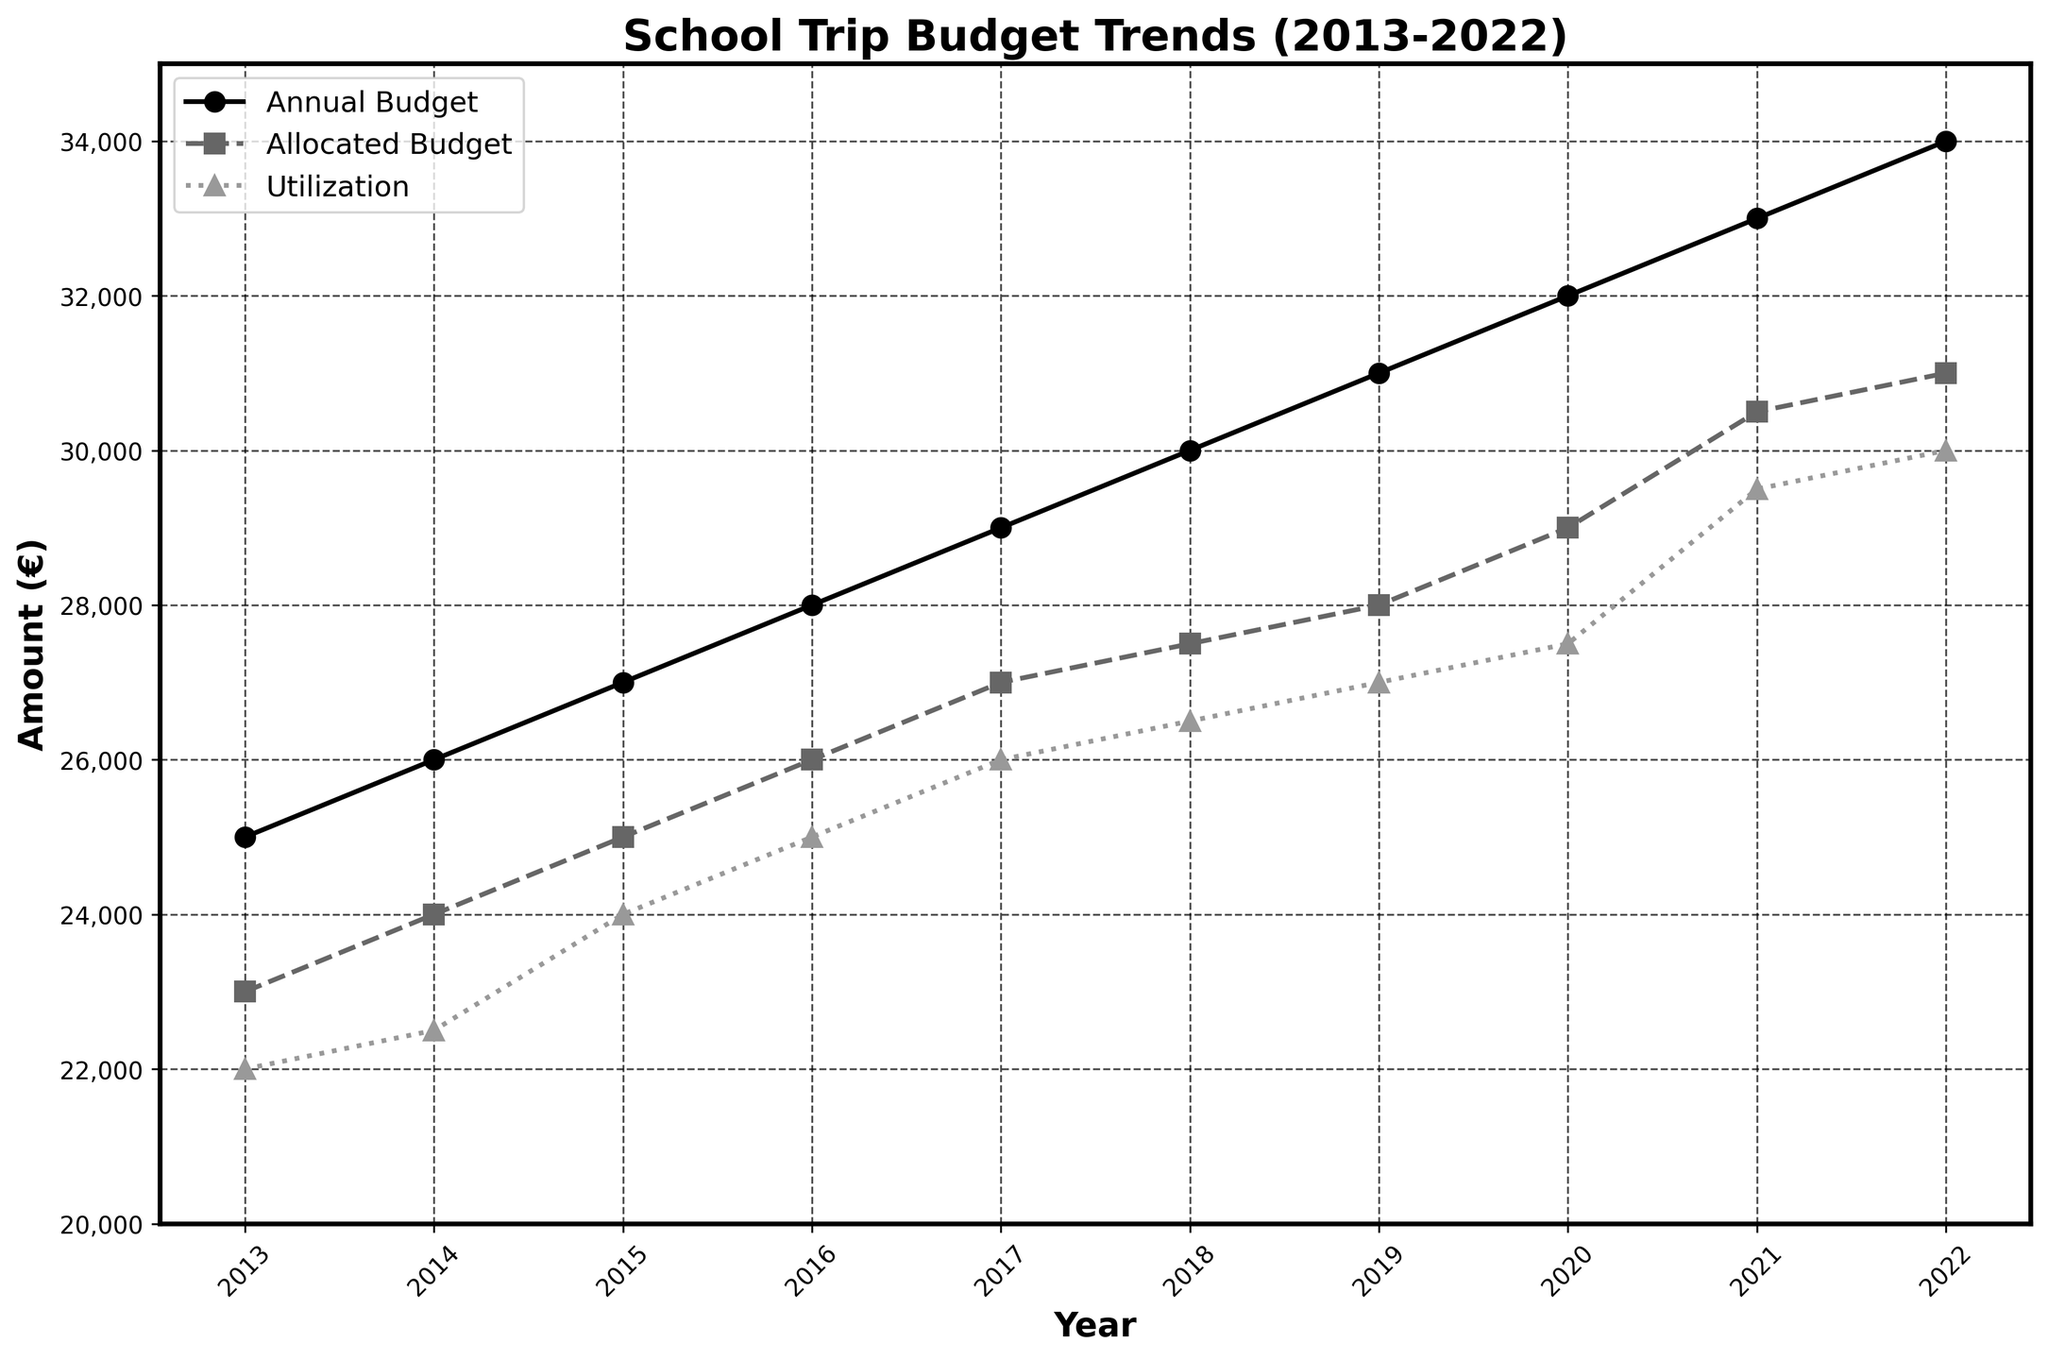What's the title of the plot? The title is displayed at the top of the plot.
Answer: School Trip Budget Trends (2013-2022) What's the highest annual budget from 2013 to 2022? Identify the highest data point in the 'Annual Budget' line.
Answer: €34,000 Which year had the lowest utilization amount? Identify the lowest data point in the 'Utilization' line.
Answer: 2013 How much more was the annual budget compared to the utilization in 2022? Subtract the utilization value from the annual budget value for 2022: €34,000 - €30,000.
Answer: €4,000 In which year did the allocated budget first exceed €30,000? Find the year where the 'Allocated Budget' line crosses €30,000 the first time.
Answer: 2021 Which budget line shows a consistent increase every year? Review each of the three lines (Annual, Allocated, Utilization) and identify which increases every year without any decrease.
Answer: All three How did the utilization trend compare to the allocated budget trend between 2015 and 2020? Observe both the 'Utilization' and 'Allocated Budget' lines from 2015 to 2020, noting the patterns: Both lines show an increasing trend but the Utilization always remains slightly below the Allocated Budget.
Answer: Both lines increased steadily; Utilization was slightly lower What's the average annual budget from 2013 to 2016? Sum the annual budgets from 2013 to 2016 and divide by the number of years: (€25,000 + €26,000 + €27,000 + €28,000) / 4 = €106,000 / 4.
Answer: €26,500 Compare the growth in allocated budget from 2018 to 2019 with the growth in utilization for the same period. Which grew more and by how much? Subtract the 2018 values from the 2019 values for both the 'Allocated Budget' and 'Utilization', then compare the differences (€28,000 - €27,500) = €500 vs (€27,000 - €26,500) = €500. Both grew by the same amount, €500.
Answer: Both increased by €500 Which year shows the smallest gap between allocated budget and utilization? Calculate the difference between allocated budget and utilization for each year and identify the smallest gap.
Answer: 2021 (€30,500 - €29,500 = €1,000) 